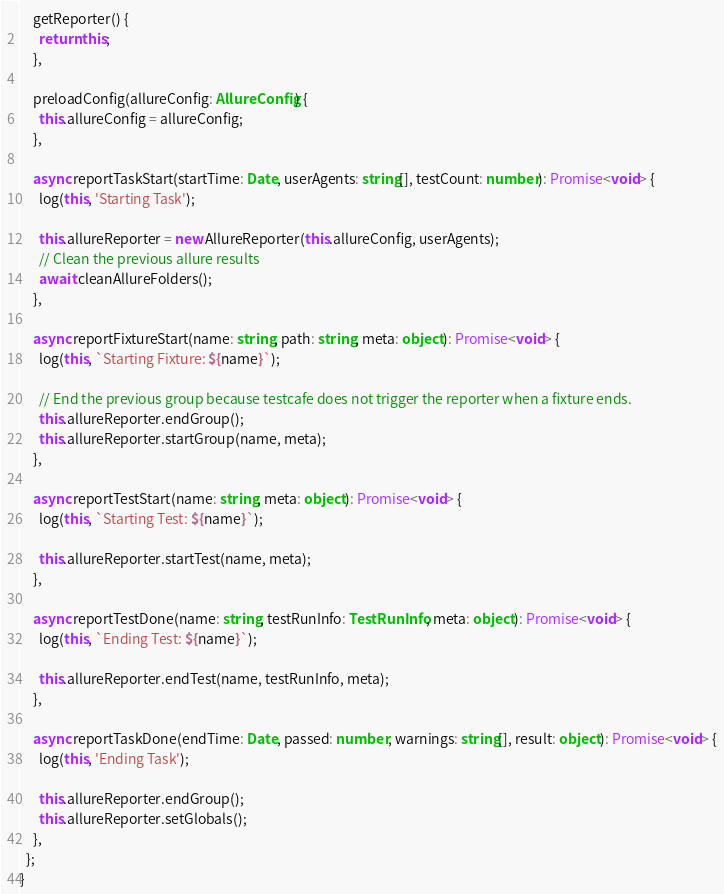<code> <loc_0><loc_0><loc_500><loc_500><_TypeScript_>    getReporter() {
      return this;
    },

    preloadConfig(allureConfig: AllureConfig) {
      this.allureConfig = allureConfig;
    },

    async reportTaskStart(startTime: Date, userAgents: string[], testCount: number): Promise<void> {
      log(this, 'Starting Task');

      this.allureReporter = new AllureReporter(this.allureConfig, userAgents);
      // Clean the previous allure results
      await cleanAllureFolders();
    },

    async reportFixtureStart(name: string, path: string, meta: object): Promise<void> {
      log(this, `Starting Fixture: ${name}`);

      // End the previous group because testcafe does not trigger the reporter when a fixture ends.
      this.allureReporter.endGroup();
      this.allureReporter.startGroup(name, meta);
    },

    async reportTestStart(name: string, meta: object): Promise<void> {
      log(this, `Starting Test: ${name}`);

      this.allureReporter.startTest(name, meta);
    },

    async reportTestDone(name: string, testRunInfo: TestRunInfo, meta: object): Promise<void> {
      log(this, `Ending Test: ${name}`);

      this.allureReporter.endTest(name, testRunInfo, meta);
    },

    async reportTaskDone(endTime: Date, passed: number, warnings: string[], result: object): Promise<void> {
      log(this, 'Ending Task');

      this.allureReporter.endGroup();
      this.allureReporter.setGlobals();
    },
  };
}
</code> 